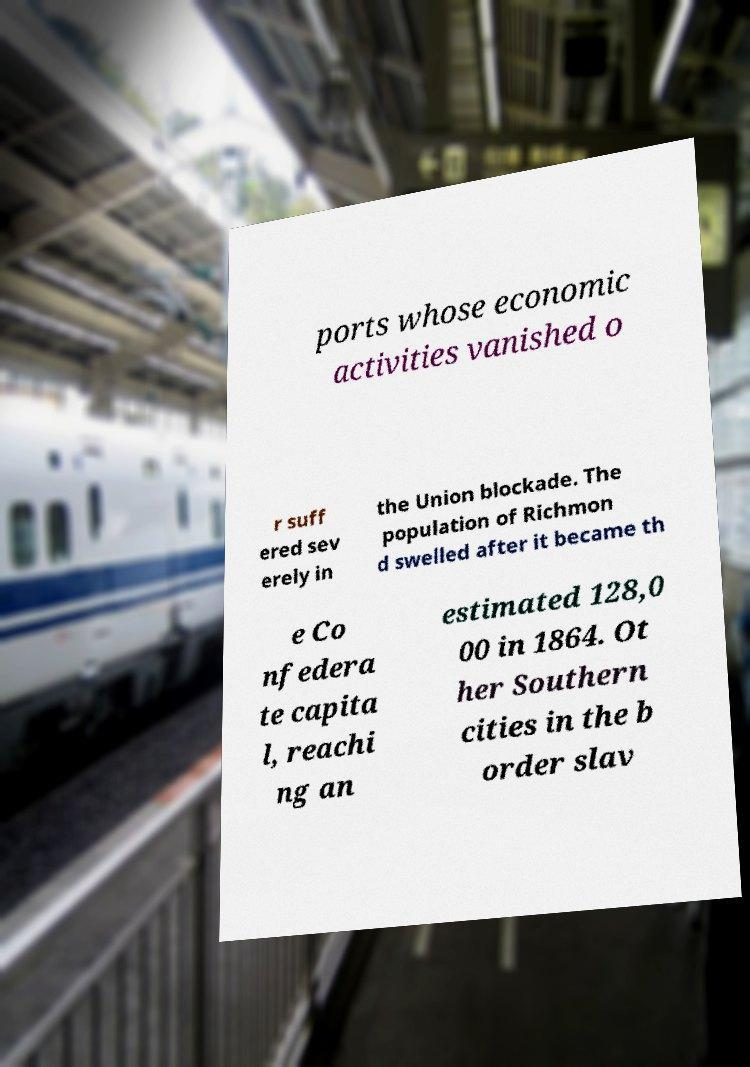For documentation purposes, I need the text within this image transcribed. Could you provide that? ports whose economic activities vanished o r suff ered sev erely in the Union blockade. The population of Richmon d swelled after it became th e Co nfedera te capita l, reachi ng an estimated 128,0 00 in 1864. Ot her Southern cities in the b order slav 